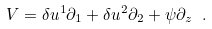Convert formula to latex. <formula><loc_0><loc_0><loc_500><loc_500>V = \delta u ^ { 1 } \partial _ { 1 } + \delta u ^ { 2 } \partial _ { 2 } + \psi \partial _ { z } \ .</formula> 